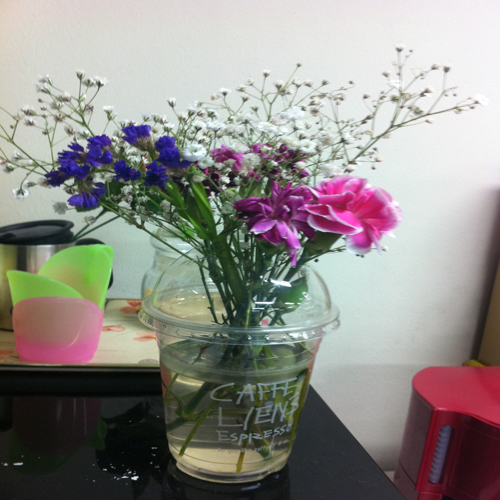Is there anything peculiar about the way the flowers are presented? It's quite unconventional to see a flower arrangement in what appears to be a reused coffee cup, suggesting a creative and perhaps environmentally conscious approach to repurposing materials. Could using a coffee cup affect the flowers? If the coffee cup is clean and has sufficient water, it shouldn't negatively impact the flowers. However, it may not provide the support and space that a traditional vase would offer, potentially affecting the longevity and presentation of the bouquet. 